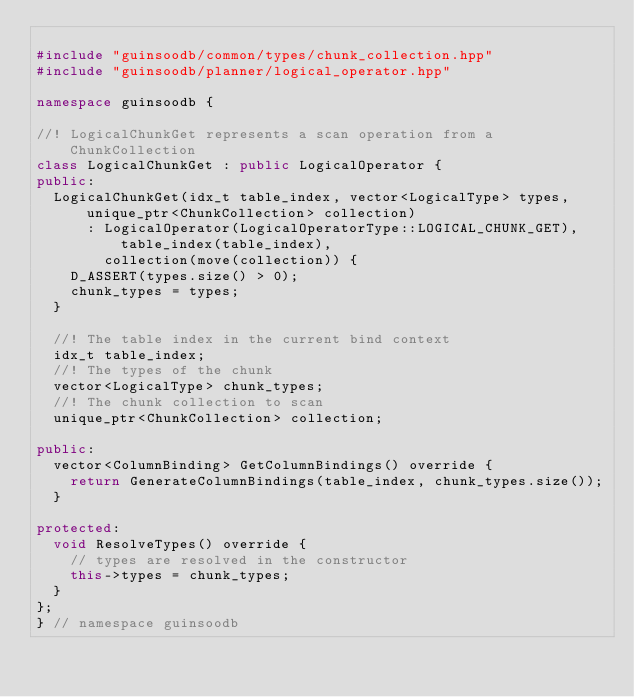<code> <loc_0><loc_0><loc_500><loc_500><_C++_>
#include "guinsoodb/common/types/chunk_collection.hpp"
#include "guinsoodb/planner/logical_operator.hpp"

namespace guinsoodb {

//! LogicalChunkGet represents a scan operation from a ChunkCollection
class LogicalChunkGet : public LogicalOperator {
public:
	LogicalChunkGet(idx_t table_index, vector<LogicalType> types, unique_ptr<ChunkCollection> collection)
	    : LogicalOperator(LogicalOperatorType::LOGICAL_CHUNK_GET), table_index(table_index),
	      collection(move(collection)) {
		D_ASSERT(types.size() > 0);
		chunk_types = types;
	}

	//! The table index in the current bind context
	idx_t table_index;
	//! The types of the chunk
	vector<LogicalType> chunk_types;
	//! The chunk collection to scan
	unique_ptr<ChunkCollection> collection;

public:
	vector<ColumnBinding> GetColumnBindings() override {
		return GenerateColumnBindings(table_index, chunk_types.size());
	}

protected:
	void ResolveTypes() override {
		// types are resolved in the constructor
		this->types = chunk_types;
	}
};
} // namespace guinsoodb
</code> 